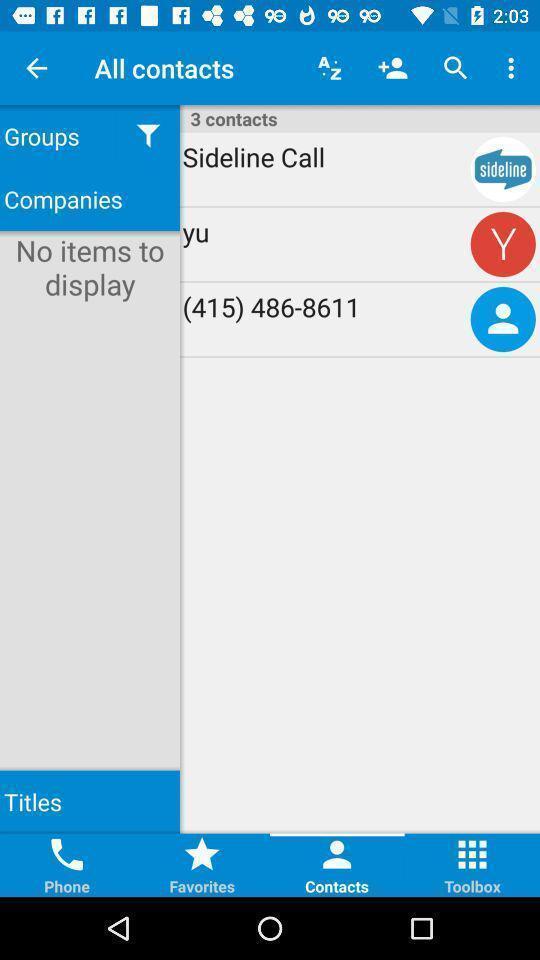Give me a summary of this screen capture. Pop up displaying multiple contacts on an app. 